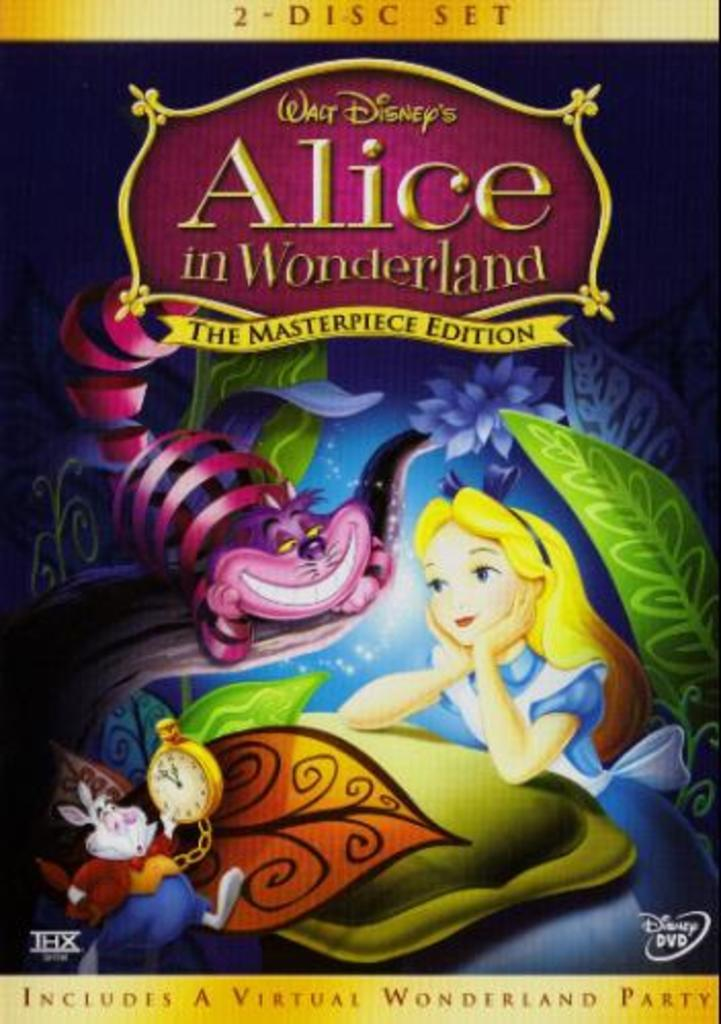Provide a one-sentence caption for the provided image. The front cover of a DVD case for Alice in Wonderland. 